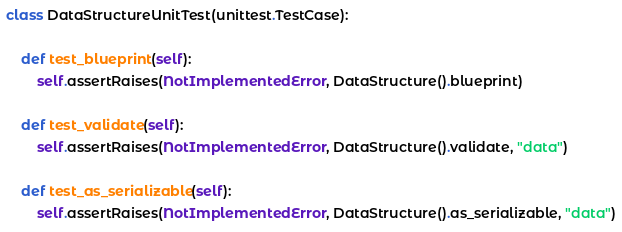<code> <loc_0><loc_0><loc_500><loc_500><_Python_>
class DataStructureUnitTest(unittest.TestCase):

    def test_blueprint(self):
        self.assertRaises(NotImplementedError, DataStructure().blueprint)

    def test_validate(self):
        self.assertRaises(NotImplementedError, DataStructure().validate, "data")

    def test_as_serializable(self):
        self.assertRaises(NotImplementedError, DataStructure().as_serializable, "data")
</code> 